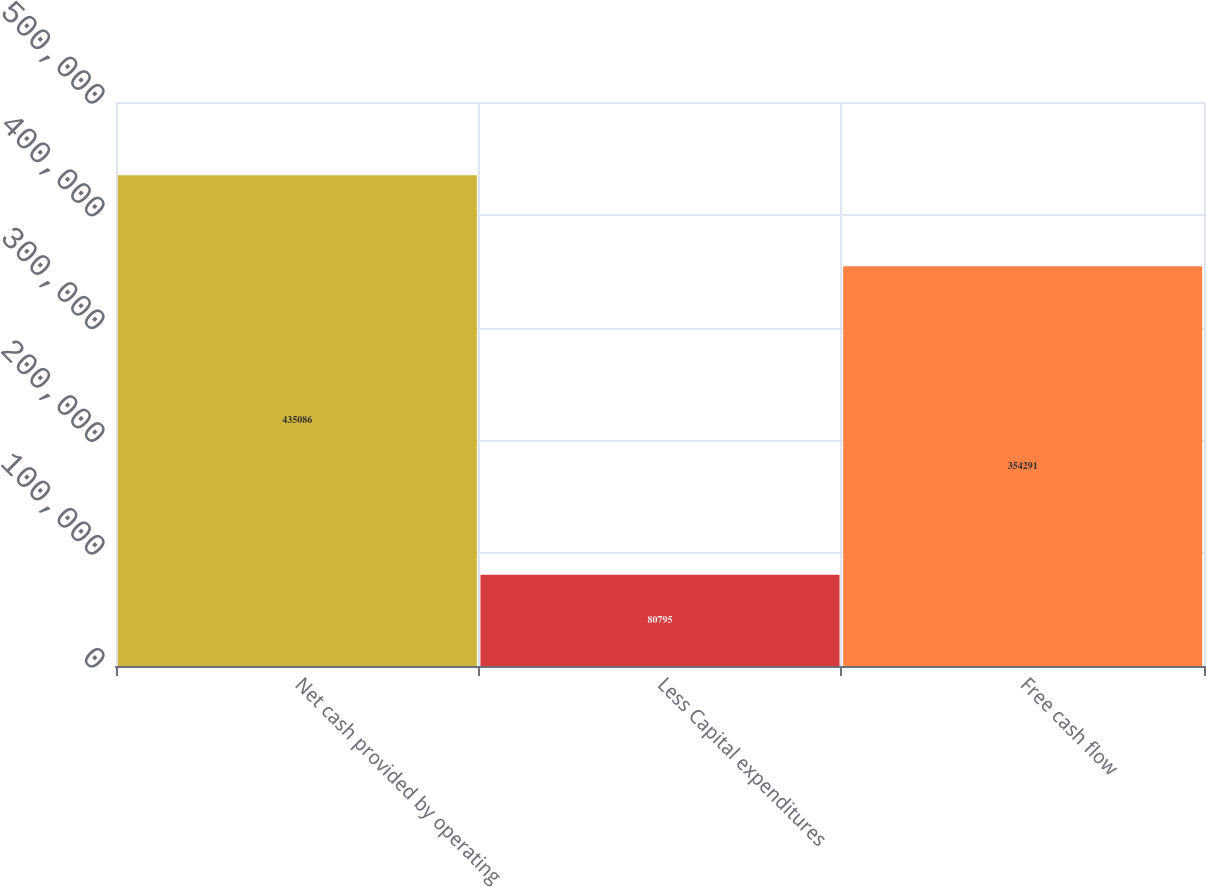Convert chart to OTSL. <chart><loc_0><loc_0><loc_500><loc_500><bar_chart><fcel>Net cash provided by operating<fcel>Less Capital expenditures<fcel>Free cash flow<nl><fcel>435086<fcel>80795<fcel>354291<nl></chart> 